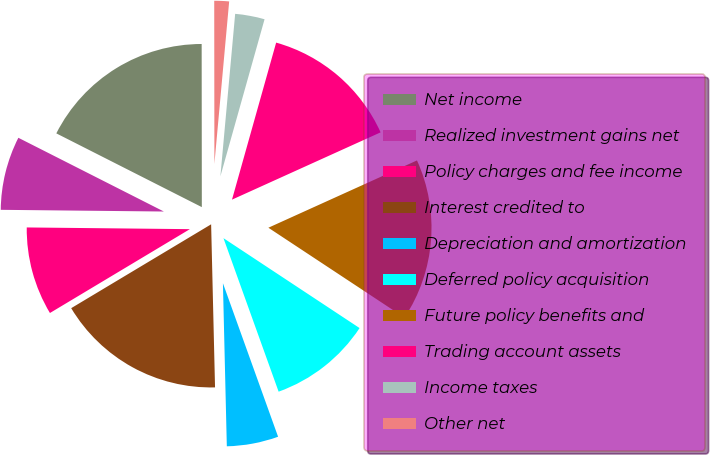<chart> <loc_0><loc_0><loc_500><loc_500><pie_chart><fcel>Net income<fcel>Realized investment gains net<fcel>Policy charges and fee income<fcel>Interest credited to<fcel>Depreciation and amortization<fcel>Deferred policy acquisition<fcel>Future policy benefits and<fcel>Trading account assets<fcel>Income taxes<fcel>Other net<nl><fcel>17.52%<fcel>7.3%<fcel>8.76%<fcel>16.79%<fcel>5.11%<fcel>10.22%<fcel>16.06%<fcel>13.87%<fcel>2.92%<fcel>1.46%<nl></chart> 